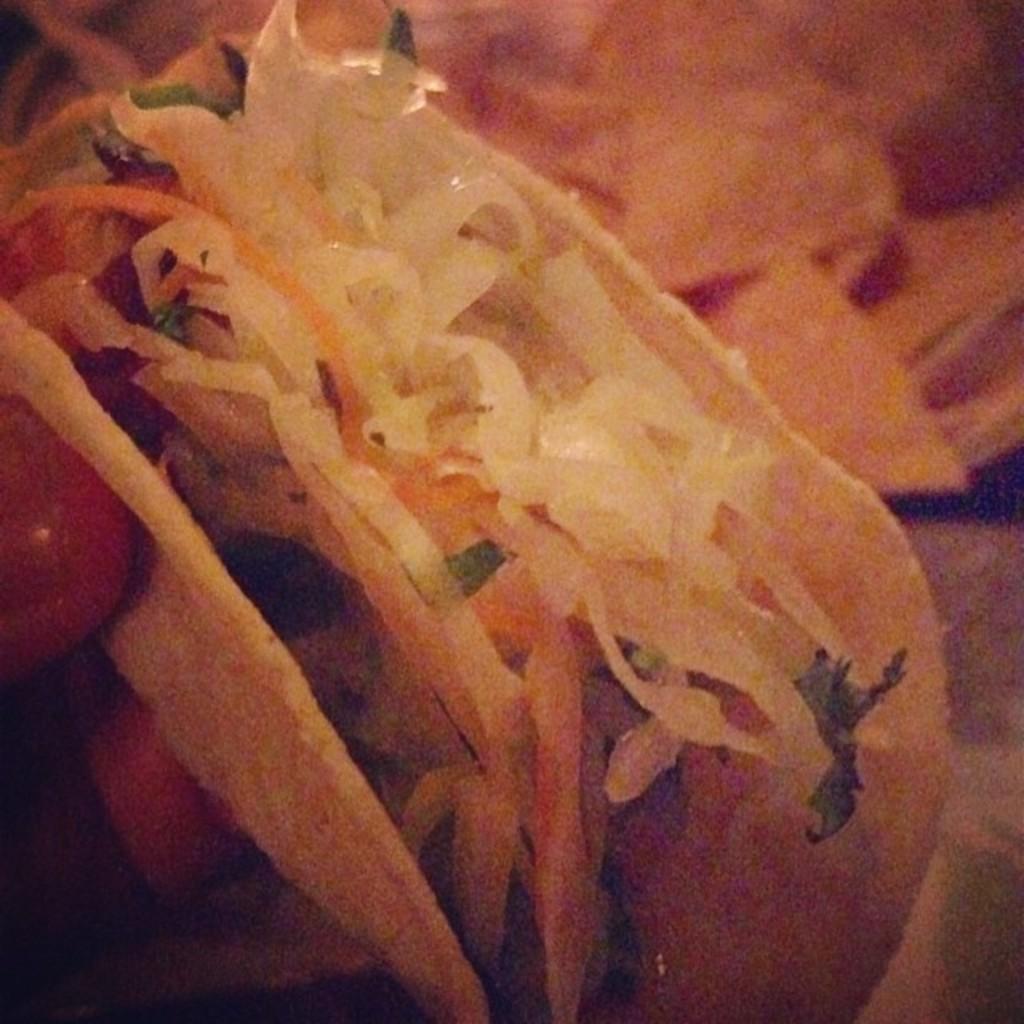Could you give a brief overview of what you see in this image? In this image I can see a person's hand holding a food item which is cream, brown and green in color. I can see the blurry background which is brown in color. 